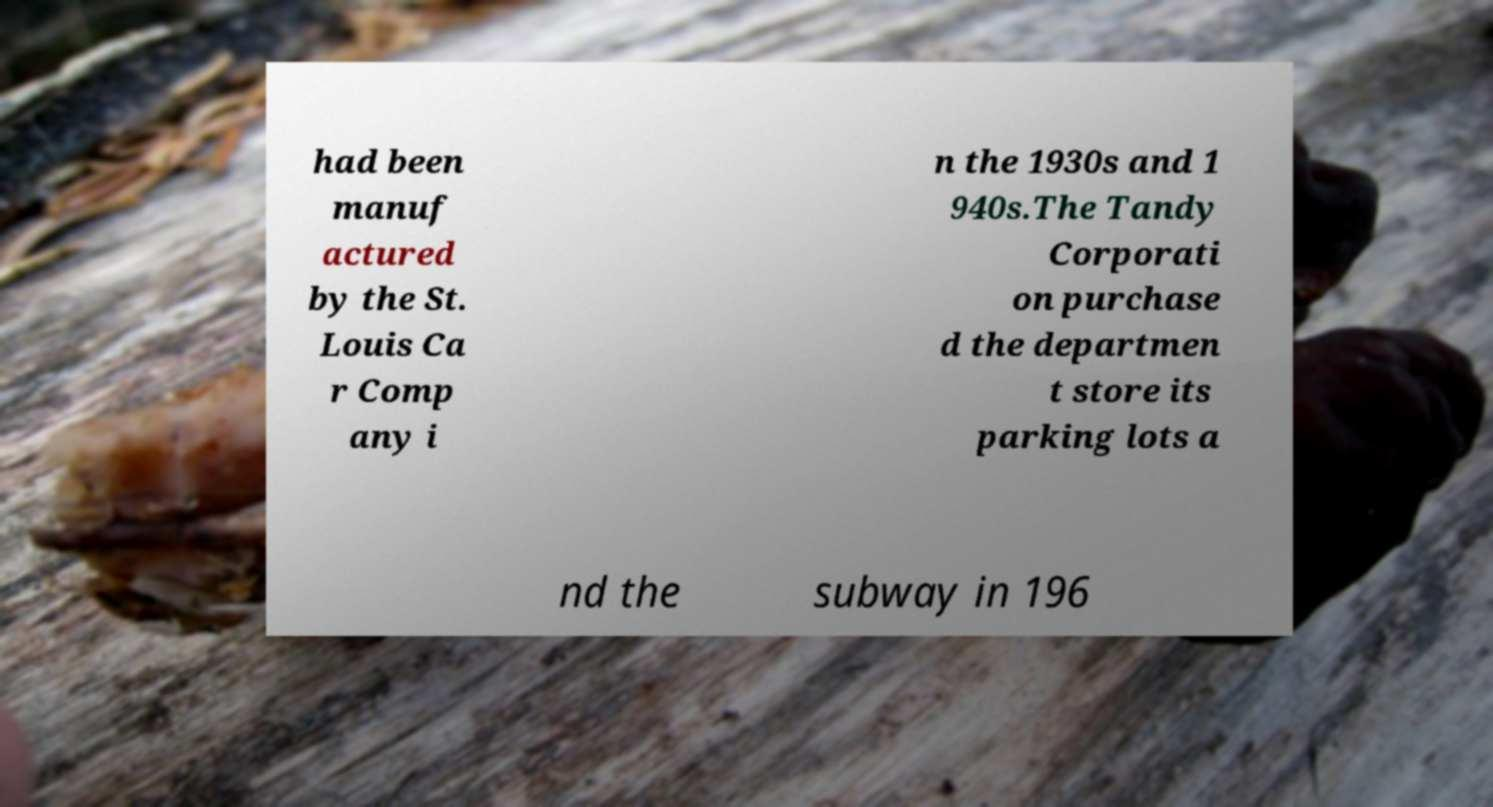Could you extract and type out the text from this image? had been manuf actured by the St. Louis Ca r Comp any i n the 1930s and 1 940s.The Tandy Corporati on purchase d the departmen t store its parking lots a nd the subway in 196 